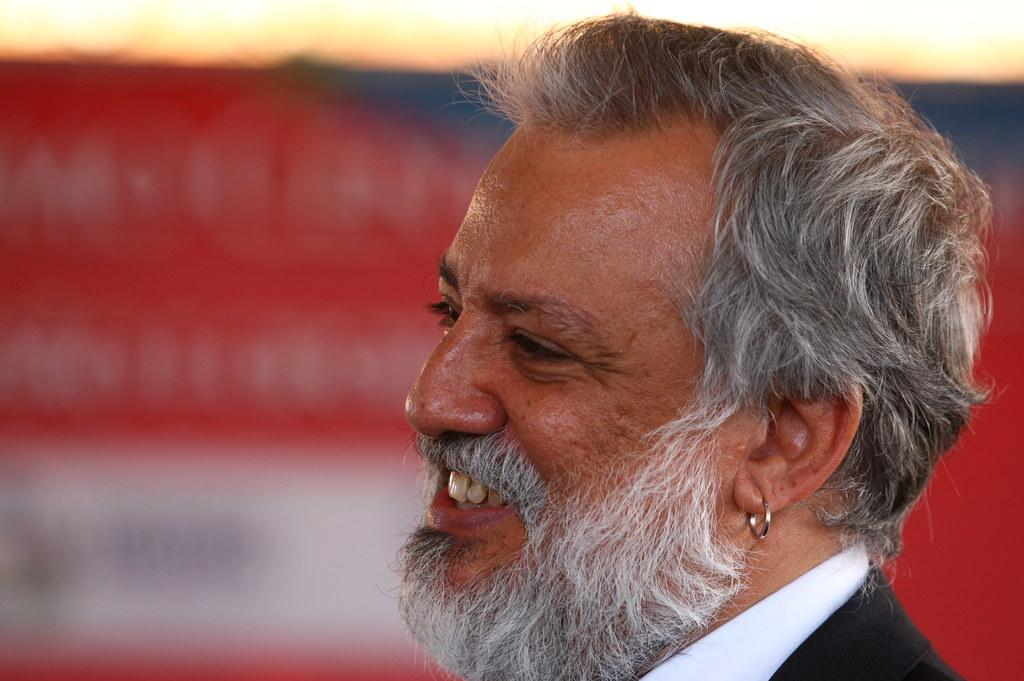Who is present in the image? There is a man in the image. What is the man's facial expression? The man is smiling. What can be seen in the background of the image? There is a board in the background of the image. What type of sponge is being used by the man in the image? There is no sponge present in the image. What letters can be seen on the board in the background? The provided facts do not mention any letters on the board, so we cannot determine if any letters are present. 